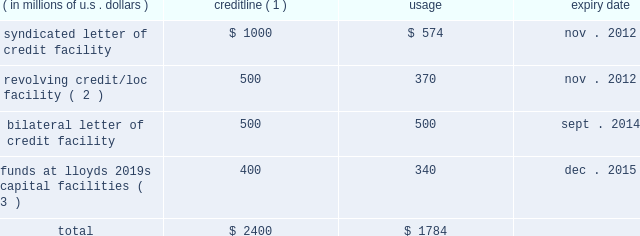Credit facilities as our bermuda subsidiaries are not admitted insurers and reinsurers in the u.s. , the terms of certain u.s .
Insurance and reinsurance contracts require them to provide collateral , which can be in the form of locs .
In addition , ace global markets is required to satisfy certain u.s .
Regulatory trust fund requirements which can be met by the issuance of locs .
Locs may also be used for general corporate purposes and to provide underwriting capacity as funds at lloyd 2019s .
The table shows our main credit facilities by credit line , usage , and expiry date at december 31 , 2010 .
( in millions of u.s .
Dollars ) credit line ( 1 ) usage expiry date .
( 1 ) certain facilities are guaranteed by operating subsidiaries and/or ace limited .
( 2 ) may also be used for locs .
( 3 ) supports ace global markets underwriting capacity for lloyd 2019s syndicate 2488 ( see discussion below ) .
In november 2010 , we entered into four letter of credit facility agreements which collectively permit the issuance of up to $ 400 million of letters of credit .
We expect that most of the locs issued under the loc agreements will be used to support the ongoing funds at lloyd 2019s requirements of syndicate 2488 , but locs may also be used for other general corporate purposes .
It is anticipated that our commercial facilities will be renewed on expiry but such renewals are subject to the availability of credit from banks utilized by ace .
In the event that such credit support is insufficient , we could be required to provide alter- native security to clients .
This could take the form of additional insurance trusts supported by our investment portfolio or funds withheld using our cash resources .
The value of letters of credit required is driven by , among other things , statutory liabilities reported by variable annuity guarantee reinsurance clients , loss development of existing reserves , the payment pattern of such reserves , the expansion of business , and loss experience of such business .
The facilities in the table above require that we maintain certain covenants , all of which have been met at december 31 , 2010 .
These covenants include : ( i ) maintenance of a minimum consolidated net worth in an amount not less than the 201cminimum amount 201d .
For the purpose of this calculation , the minimum amount is an amount equal to the sum of the base amount ( currently $ 13.8 billion ) plus 25 percent of consolidated net income for each fiscal quarter , ending after the date on which the current base amount became effective , plus 50 percent of any increase in consolidated net worth during the same period , attributable to the issuance of common and preferred shares .
The minimum amount is subject to an annual reset provision .
( ii ) maintenance of a maximum debt to total capitalization ratio of not greater than 0.35 to 1 .
Under this covenant , debt does not include trust preferred securities or mezzanine equity , except where the ratio of the sum of trust preferred securities and mezzanine equity to total capitalization is greater than 15 percent .
In this circumstance , the amount greater than 15 percent would be included in the debt to total capitalization ratio .
At december 31 , 2010 , ( a ) the minimum consolidated net worth requirement under the covenant described in ( i ) above was $ 14.5 billion and our actual consolidated net worth as calculated under that covenant was $ 21.6 billion and ( b ) our ratio of debt to total capitalization was 0.167 to 1 , which is below the maximum debt to total capitalization ratio of 0.35 to 1 as described in ( ii ) above .
Our failure to comply with the covenants under any credit facility would , subject to grace periods in the case of certain covenants , result in an event of default .
This could require us to repay any outstanding borrowings or to cash collateralize locs under such facility .
A failure by ace limited ( or any of its subsidiaries ) to pay an obligation due for an amount exceeding $ 50 million would result in an event of default under all of the facilities described above .
Ratings ace limited and its subsidiaries are assigned debt and financial strength ( insurance ) ratings from internationally recognized rating agencies , including s&p , a.m .
Best , moody 2019s investors service , and fitch .
The ratings issued on our companies by these agencies are announced publicly and are available directly from the agencies .
Our internet site , www.acegroup.com .
What is the total credit line utilization rate? 
Computations: (1784 / 2400)
Answer: 0.74333. 